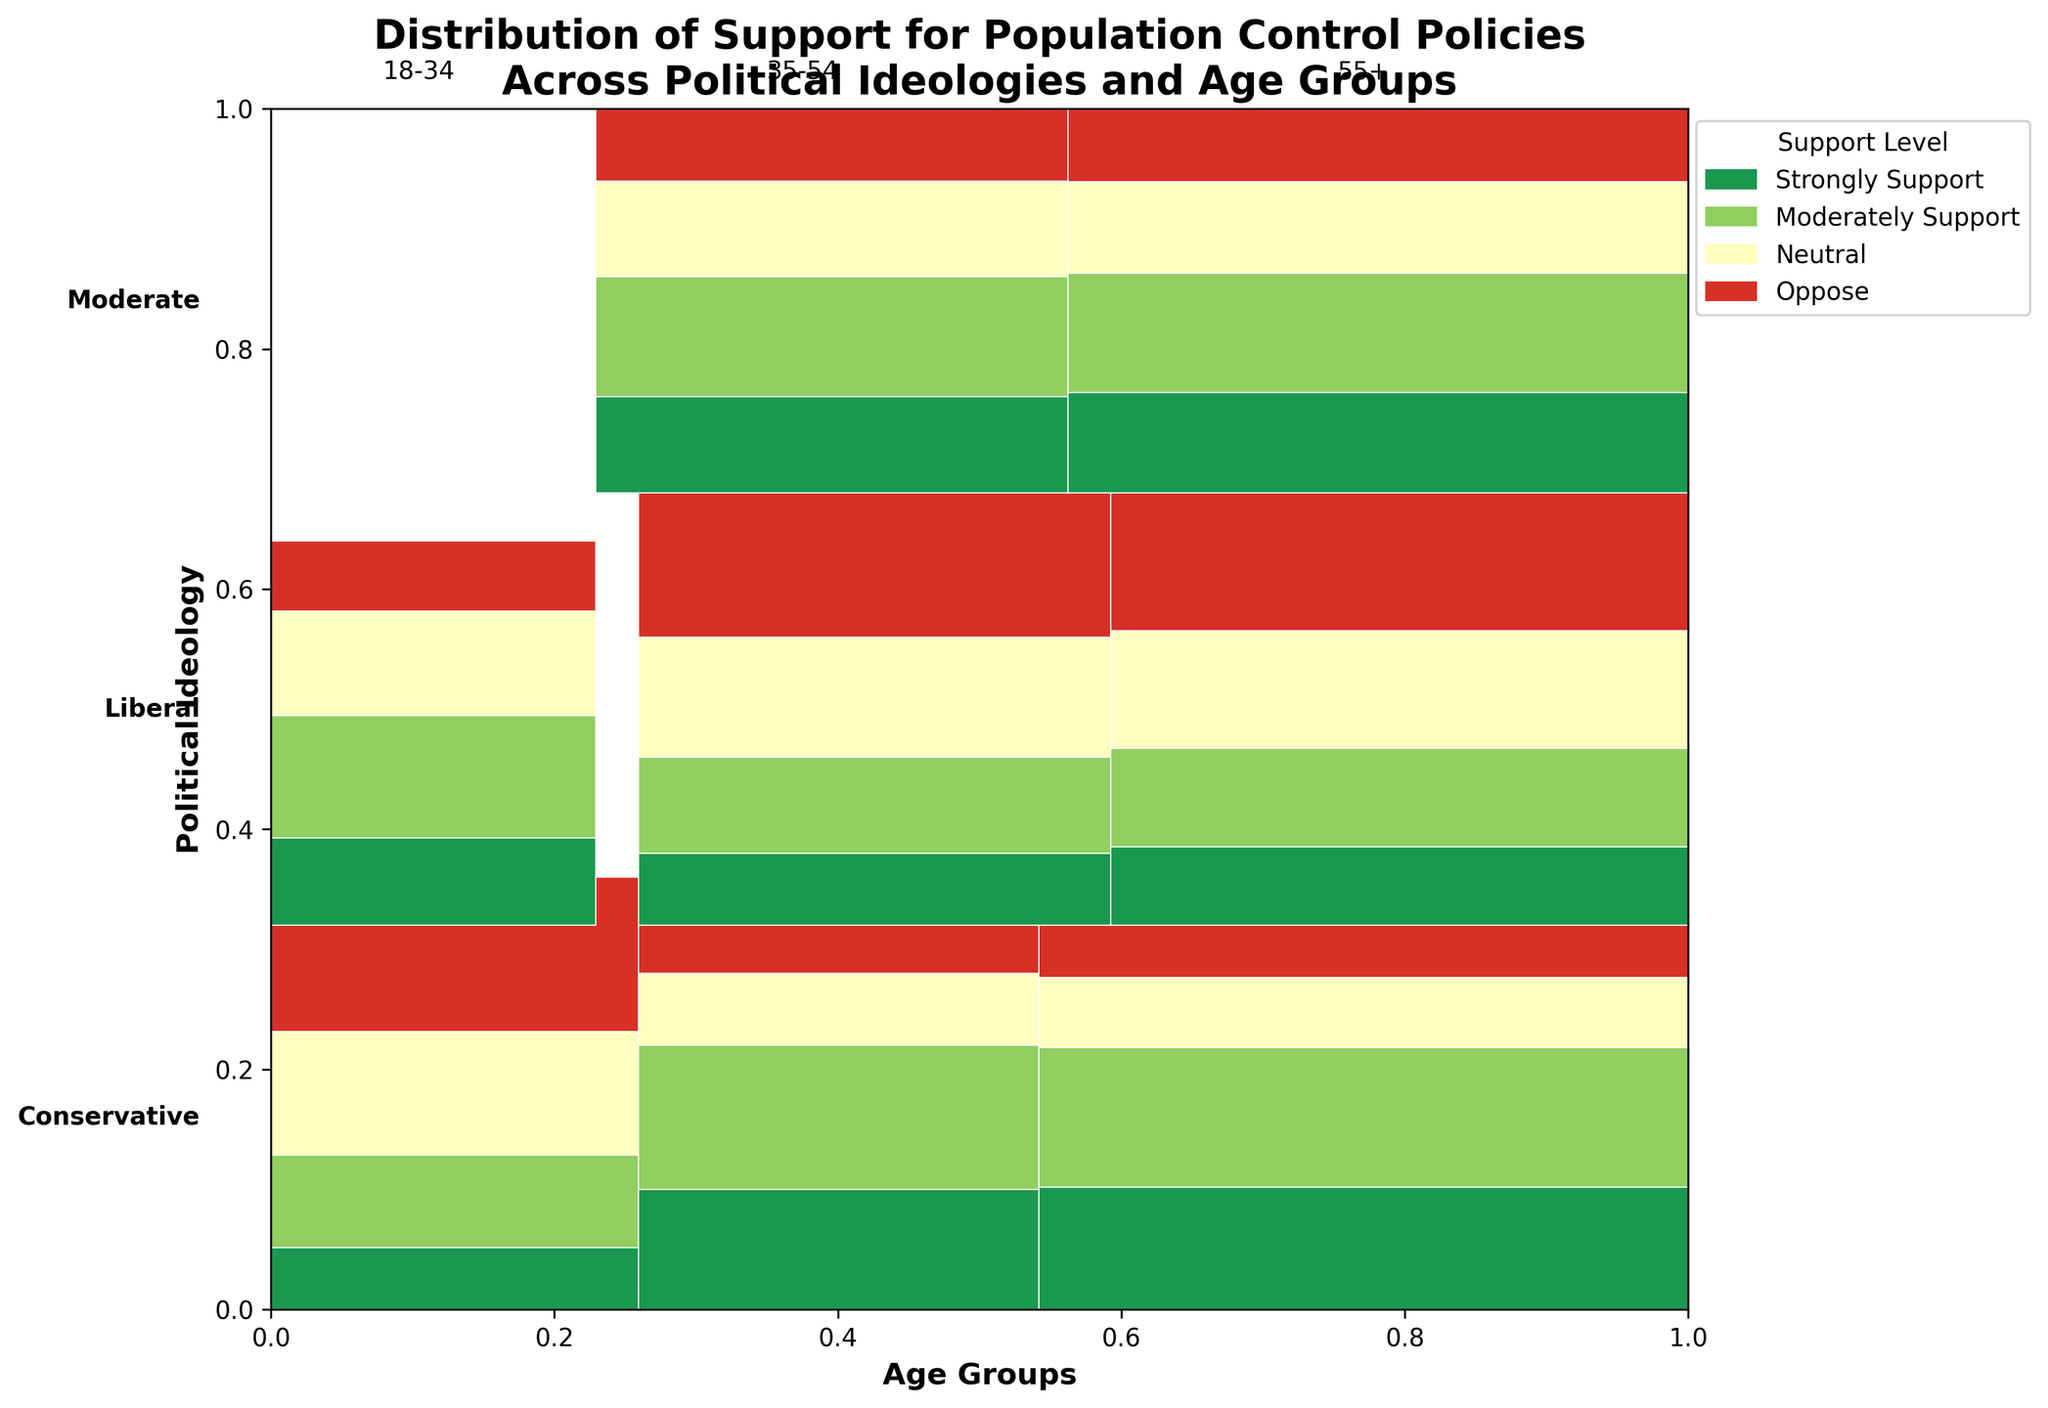What is the title of the figure? The title is typically displayed prominently at the top of the mosaic plot. By reading it, we can directly identify the topic of the figure.
Answer: Distribution of Support for Population Control Policies Across Political Ideologies and Age Groups Which age group within conservatives shows the highest support for population control policies? By examining the sections for each age group within the conservative ideology, you can compare their sizes. The largest sections correspond to "Strongly Support" and "Moderately Support" levels.
Answer: 55+ What is the color used for "Oppose" in the mosaic plot? Refer to the legend on the figure which maps support levels to colors. Find the color corresponding to "Oppose."
Answer: Red Do liberals aged 18-34 mostly support or oppose population control measures? Compare the sizes of the corresponding boxes for "Strongly Support," "Moderately Support," "Neutral," and "Oppose" for liberals aged 18-34. The largest box indicates the majority opinion.
Answer: Oppose How does the support for population control among moderates aged 35-54 compare to that of conservatives aged 35-54? Compare the sizes of the "Strongly Support" and "Moderately Support" sections for moderates aged 35-54 to the corresponding sections for conservatives aged 35-54.
Answer: Moderates show less support than conservatives Which group shows the most neutrality towards population control policies? Compare the "Neutral" segments across all ideological and age groups. The largest segment represents the highest neutrality.
Answer: Liberals aged 55+ What is the overall strongest support level among conservatives? Looking at all age groups within the conservative box, sum up the counts for "Strongly Support" and compare it with other support levels.
Answer: Strongly Support How does the opposition level among conservatives aged 55+ compare with that among liberals aged 55+? Examine the size of the "Oppose" sections for conservatives aged 55+ and liberals aged 55+. Compare these visually.
Answer: Conservatives show less opposition than liberals Which age group within moderates shows the highest neutrality towards population control policies? Look at the "Neutral" sections within each age group in the moderate ideology and compare their sizes.
Answer: 55+ 